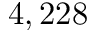<formula> <loc_0><loc_0><loc_500><loc_500>4 , 2 2 8</formula> 